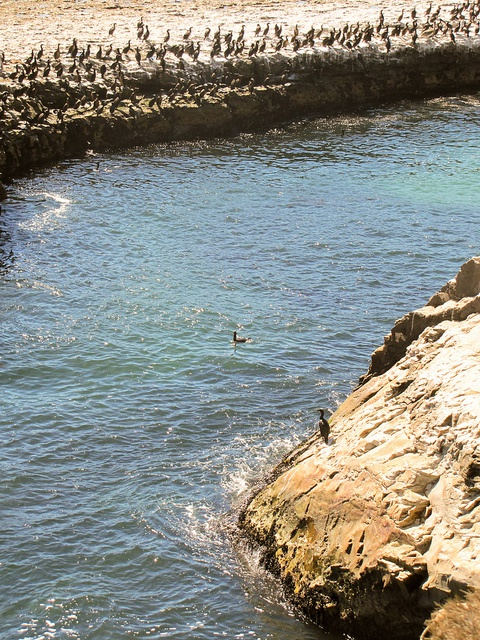Describe the objects in this image and their specific colors. I can see bird in tan, black, and gray tones, bird in tan, gray, black, and darkgray tones, bird in tan, black, and gray tones, bird in tan, black, maroon, and gray tones, and bird in tan, gray, and black tones in this image. 